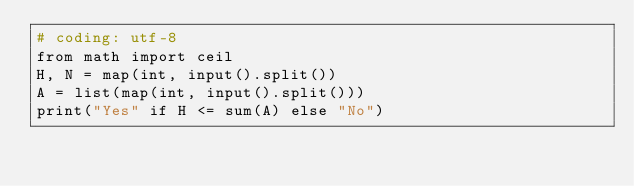<code> <loc_0><loc_0><loc_500><loc_500><_Python_># coding: utf-8
from math import ceil
H, N = map(int, input().split())
A = list(map(int, input().split()))
print("Yes" if H <= sum(A) else "No")</code> 